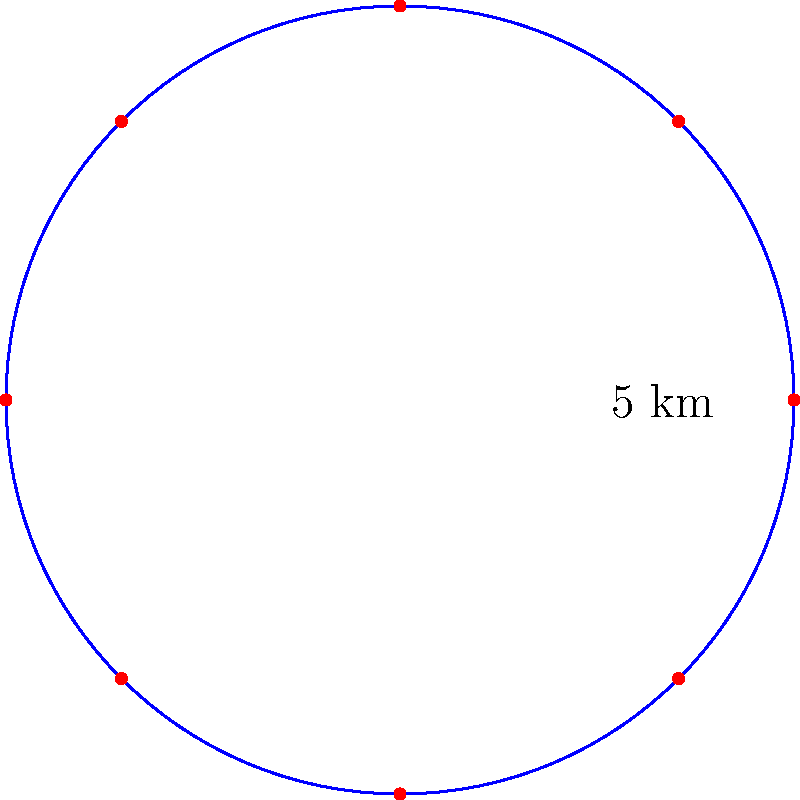You're designing a circular wind farm layout with 8 turbines evenly spaced around the perimeter. If the radius of the circle is 5 km, what is the total distance between adjacent turbines along the perimeter of the wind farm? Round your answer to the nearest meter. To solve this problem, we'll follow these steps:

1) First, we need to calculate the circumference of the circle. The formula for circumference is:
   
   $$C = 2\pi r$$

   Where $r$ is the radius.

2) Plugging in our radius of 5 km:
   
   $$C = 2\pi (5) = 10\pi \text{ km}$$

3) Now, we need to find the length of one segment (the distance between two adjacent turbines). Since there are 8 turbines evenly spaced, there are 8 equal segments. To find the length of one segment, we divide the circumference by 8:

   $$\text{Segment length} = \frac{10\pi}{8} \text{ km}$$

4) Simplify:
   
   $$\text{Segment length} = \frac{5\pi}{4} \text{ km}$$

5) Convert to meters:
   
   $$\text{Segment length} = \frac{5\pi}{4} \times 1000 \text{ m} = 3927.0 \text{ m}$$

6) Rounding to the nearest meter:
   
   $$\text{Segment length} \approx 3927 \text{ m}$$

Thus, the total distance between adjacent turbines along the perimeter is approximately 3927 meters.
Answer: 3927 m 